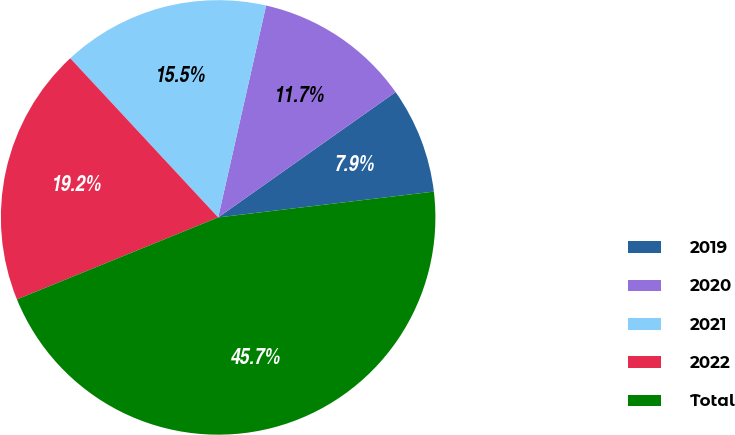Convert chart to OTSL. <chart><loc_0><loc_0><loc_500><loc_500><pie_chart><fcel>2019<fcel>2020<fcel>2021<fcel>2022<fcel>Total<nl><fcel>7.89%<fcel>11.67%<fcel>15.46%<fcel>19.24%<fcel>45.74%<nl></chart> 